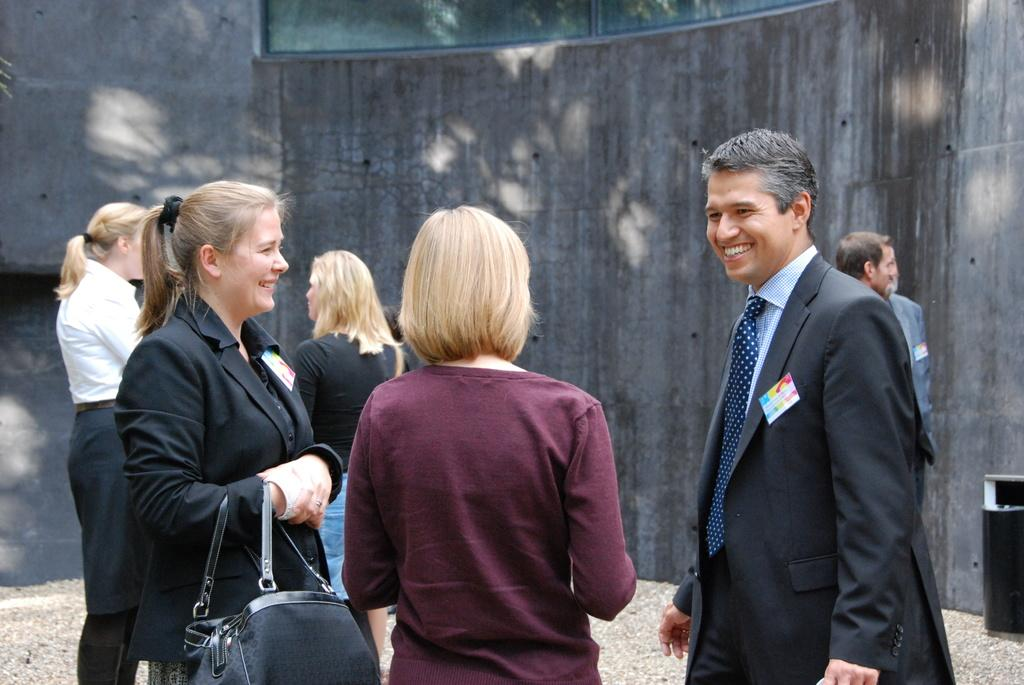How many people are in the image? There is a group of people standing in the image. What can be seen in the background of the image? There is a wall and a dustbin in the background of the image. Where is the rabbit hiding in the image? There is no rabbit present in the image. What is in the pocket of the person standing on the left side of the image? The provided facts do not mention any pockets or items in pockets, so we cannot answer this question. 